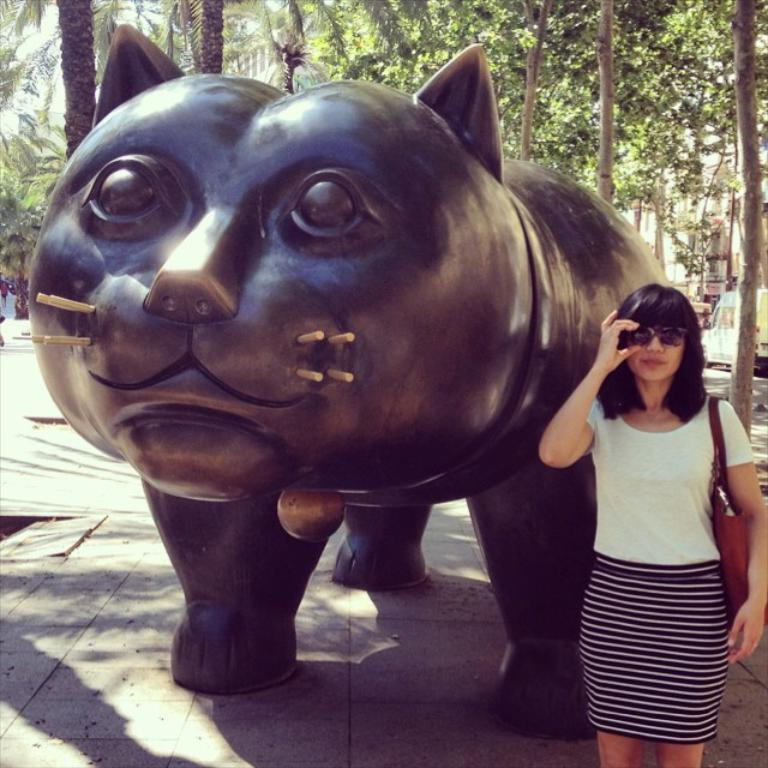What type of animal is depicted as a statue in the image? There is a statue of an animal in the image, but the specific animal cannot be determined from the provided facts. What is the person holding in the image? The person is holding a bag and sunglasses in the image. What can be seen on the ground in the image? The ground is visible in the image, but no specific details about the ground can be determined from the provided facts. What type of vegetation is present in the image? There are trees in the image. What type of structures can be seen in the image? There are buildings in the image. What mode of transportation is present in the image? A vehicle is present in the image. What is visible in the sky in the image? The sky is visible in the image, but no specific details about the sky can be determined from the provided facts. Where is the kitty wearing a sweater sitting in the image? There is no kitty wearing a sweater present in the image. What type of lamp is illuminating the scene in the image? There is no lamp present in the image. 